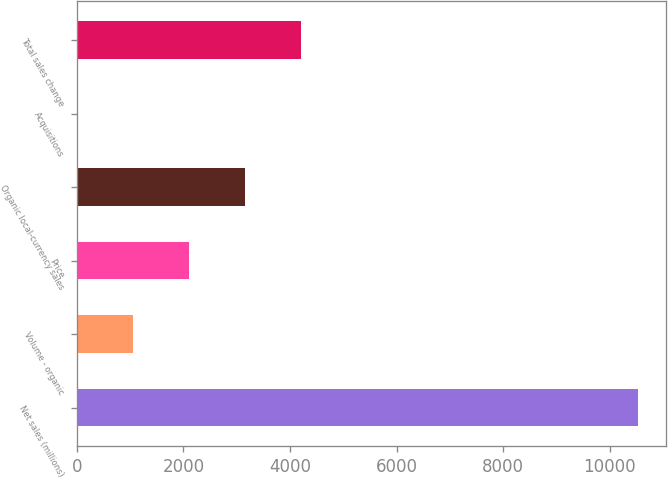Convert chart to OTSL. <chart><loc_0><loc_0><loc_500><loc_500><bar_chart><fcel>Net sales (millions)<fcel>Volume - organic<fcel>Price<fcel>Organic local-currency sales<fcel>Acquisitions<fcel>Total sales change<nl><fcel>10528<fcel>1053.52<fcel>2106.24<fcel>3158.96<fcel>0.8<fcel>4211.68<nl></chart> 